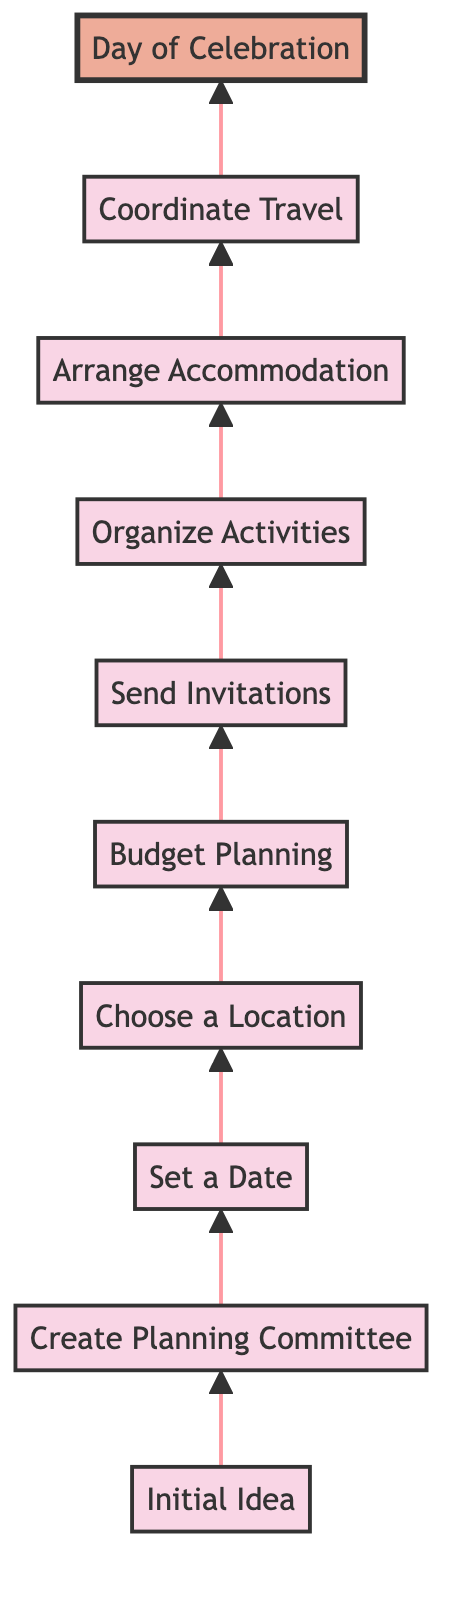What is the first step in planning a family reunion? The first step in the flow chart, indicated at the bottom, is "Initial Idea." This step involves discussing the concept of the family reunion to gauge interest among close family members.
Answer: Initial Idea How many total steps are involved in the family reunion planning process? By counting the distinct steps listed in the flow chart from "Initial Idea" to "Day of Celebration," we find that there are 10 steps in total.
Answer: 10 What step follows "Create Planning Committee"? The step that follows "Create Planning Committee" in the flow chart is "Set a Date." This indicates the chronological order of planning activities.
Answer: Set a Date What is the last step in the diagram? The last step, which is located at the top of the flow chart, is "Day of Celebration." This represents the culmination of all planning efforts before the actual event.
Answer: Day of Celebration Which step involves preparing and sending out invitations? The step focused on invitations is labeled "Send Invitations." This process occurs after budget planning and before organizing activities.
Answer: Send Invitations Which two steps are directly connected before organizing activities? The steps directly connected before "Organize Activities" are "Send Invitations" and "Budget Planning." "Budget Planning" comes before "Send Invitations," establishing a required financial plan before reaching out to family.
Answer: Send Invitations and Budget Planning What important aspect does "Choose a Location" relate to in the sequence? "Choose a Location" is a crucial step related to setting the venue for the reunion and comes after selecting a date. It ensures that the planned date can match a suitable place for the family gathering.
Answer: Choosing a venue What is the significance of the "Coordinate Travel" step? The significance of "Coordinate Travel" is to assist family members in their travel plans, ensuring smooth arrivals and accommodations, which is vital for those coming from abroad. It happens after arranging accommodation.
Answer: Assists with travel plans Which step requires input from the different branches of the family? The step that requires input from different branches of the family is "Create a Planning Committee." This step highlights the collaboration necessary for an inclusive planning process.
Answer: Create a Planning Committee 